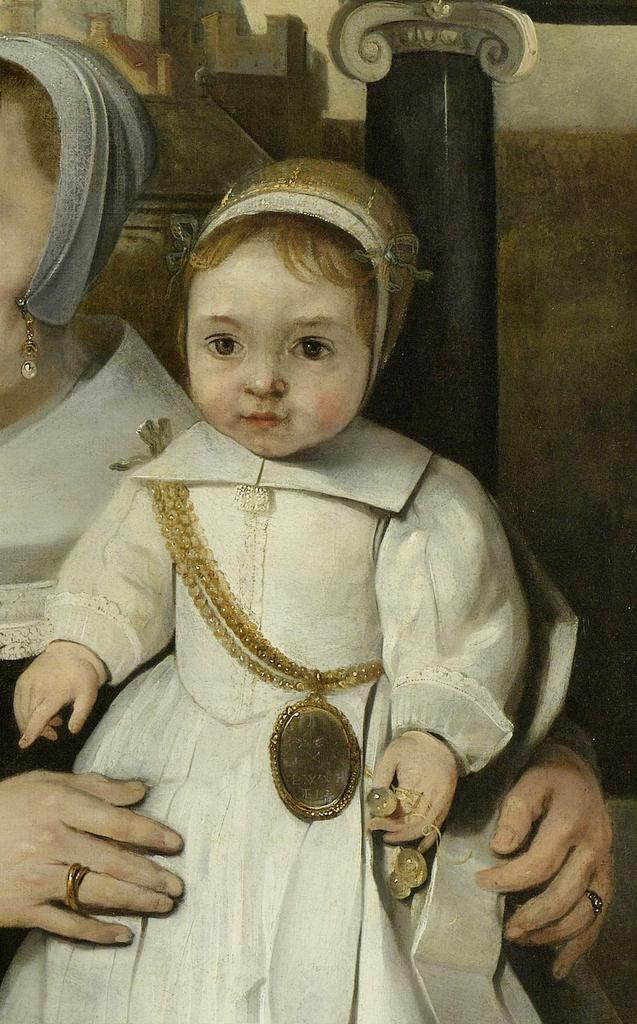What type of figure is depicted in the painting? The painting contains a person and a kid. Are there any objects or structures in the painting? Yes, there is a chain, a pillar, and a wall in the painting. What type of class is being taught by the scarecrow in the painting? There is no scarecrow present in the painting. What type of jail can be seen in the painting? There is no jail depicted in the painting. 